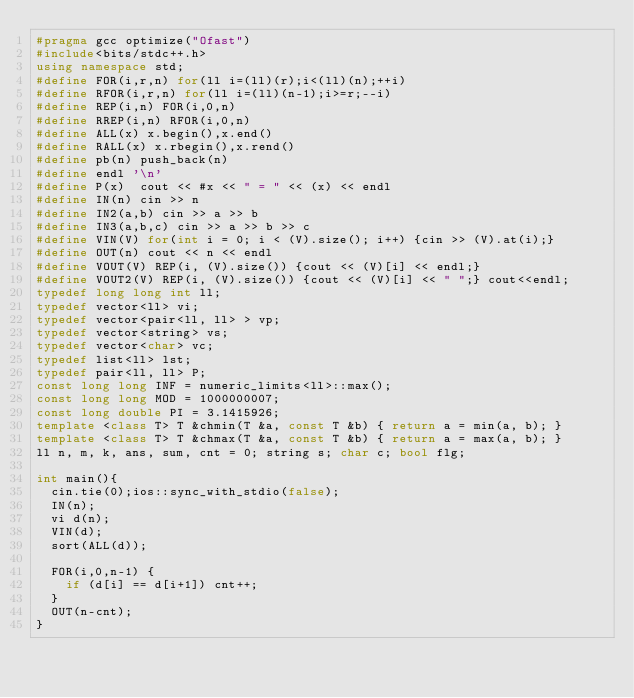<code> <loc_0><loc_0><loc_500><loc_500><_C++_>#pragma gcc optimize("Ofast")
#include<bits/stdc++.h>
using namespace std;
#define FOR(i,r,n) for(ll i=(ll)(r);i<(ll)(n);++i)
#define RFOR(i,r,n) for(ll i=(ll)(n-1);i>=r;--i)
#define REP(i,n) FOR(i,0,n)
#define RREP(i,n) RFOR(i,0,n)
#define ALL(x) x.begin(),x.end()
#define RALL(x) x.rbegin(),x.rend()
#define pb(n) push_back(n)
#define endl '\n'
#define P(x)  cout << #x << " = " << (x) << endl
#define IN(n) cin >> n
#define IN2(a,b) cin >> a >> b
#define IN3(a,b,c) cin >> a >> b >> c
#define VIN(V) for(int i = 0; i < (V).size(); i++) {cin >> (V).at(i);}
#define OUT(n) cout << n << endl
#define VOUT(V) REP(i, (V).size()) {cout << (V)[i] << endl;}
#define VOUT2(V) REP(i, (V).size()) {cout << (V)[i] << " ";} cout<<endl;
typedef long long int ll;
typedef vector<ll> vi;
typedef vector<pair<ll, ll> > vp;
typedef vector<string> vs;
typedef vector<char> vc;
typedef list<ll> lst;
typedef pair<ll, ll> P;
const long long INF = numeric_limits<ll>::max();
const long long MOD = 1000000007;
const long double PI = 3.1415926;
template <class T> T &chmin(T &a, const T &b) { return a = min(a, b); }
template <class T> T &chmax(T &a, const T &b) { return a = max(a, b); }
ll n, m, k, ans, sum, cnt = 0; string s; char c; bool flg;

int main(){
  cin.tie(0);ios::sync_with_stdio(false);
  IN(n);
  vi d(n);
  VIN(d);
  sort(ALL(d));

  FOR(i,0,n-1) {
    if (d[i] == d[i+1]) cnt++;
  }
  OUT(n-cnt);
}
</code> 